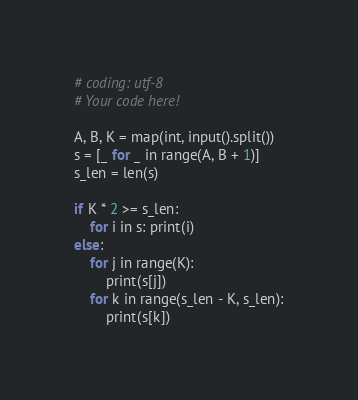Convert code to text. <code><loc_0><loc_0><loc_500><loc_500><_Python_># coding: utf-8
# Your code here!

A, B, K = map(int, input().split())
s = [_ for _ in range(A, B + 1)]
s_len = len(s)

if K * 2 >= s_len:
    for i in s: print(i)
else:
    for j in range(K):
        print(s[j])
    for k in range(s_len - K, s_len):
        print(s[k])</code> 